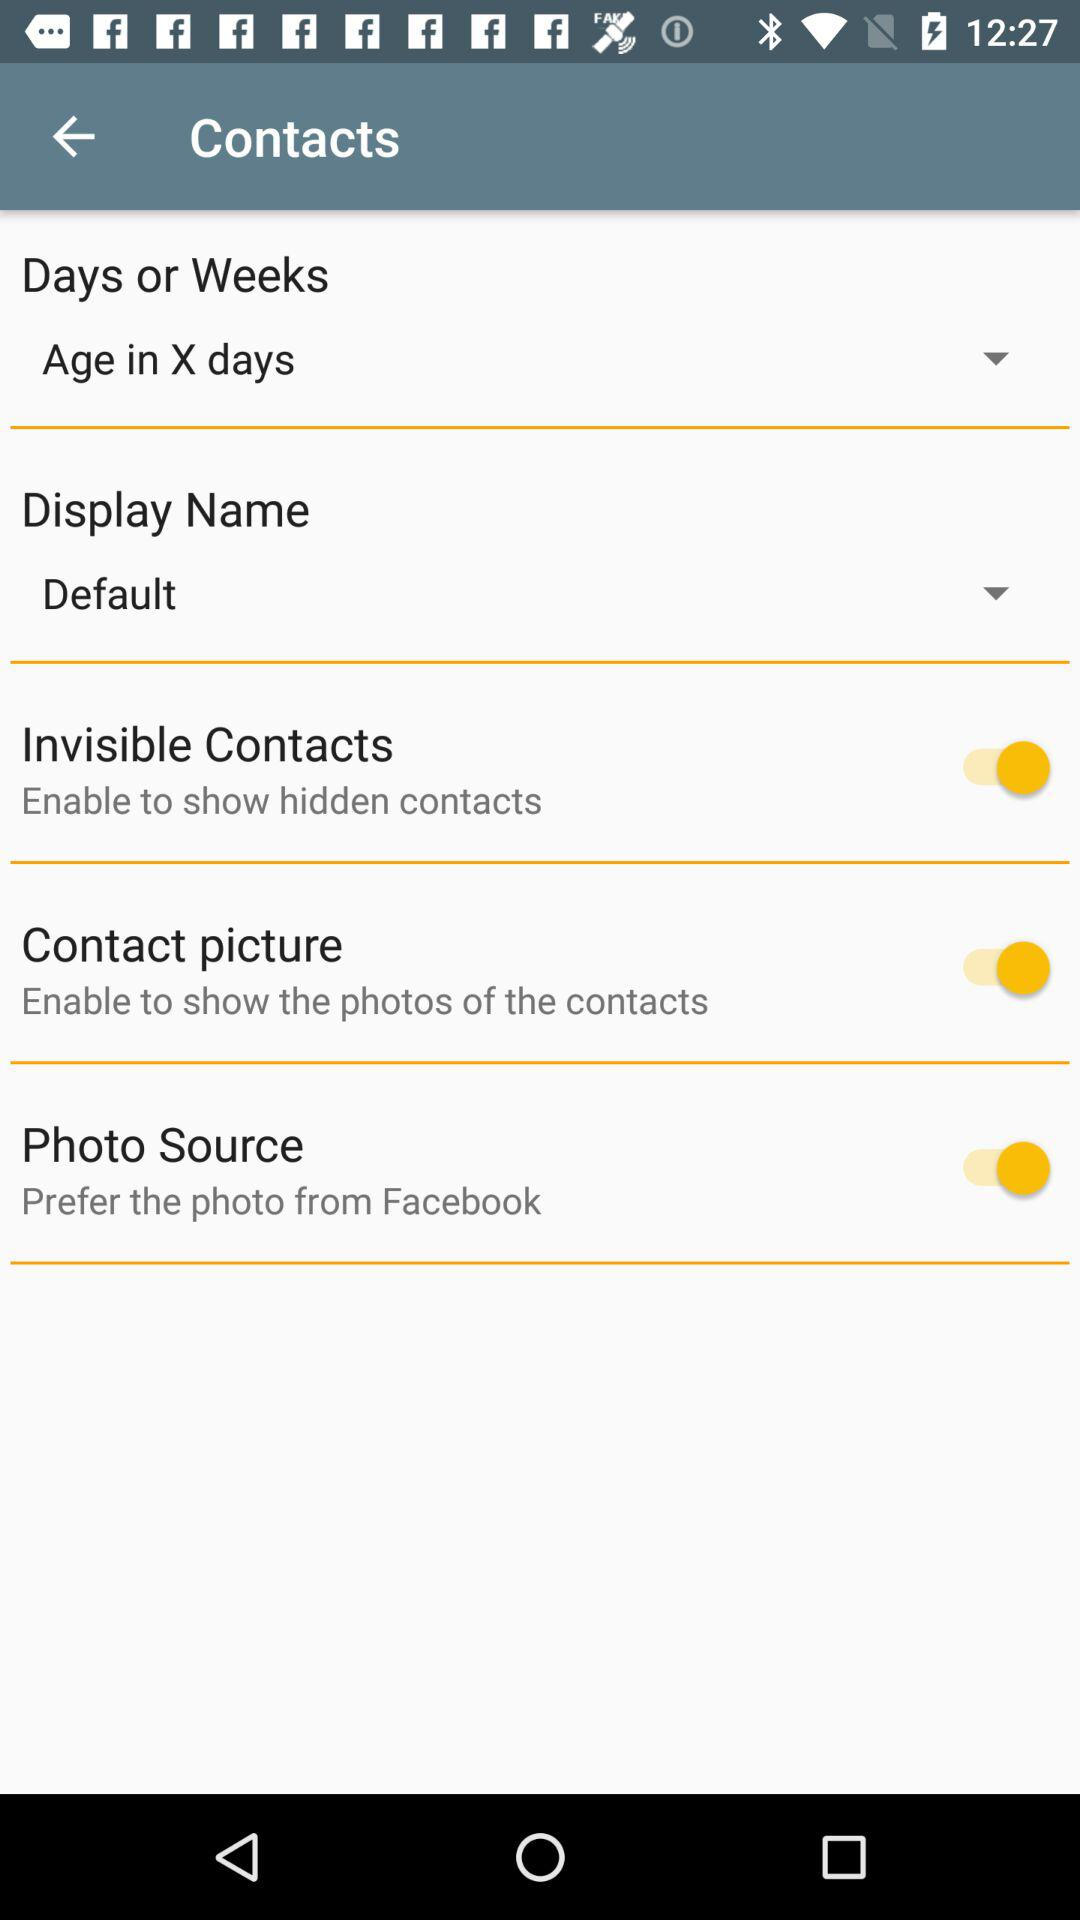What is the selected display name? The selected display name is "Default". 